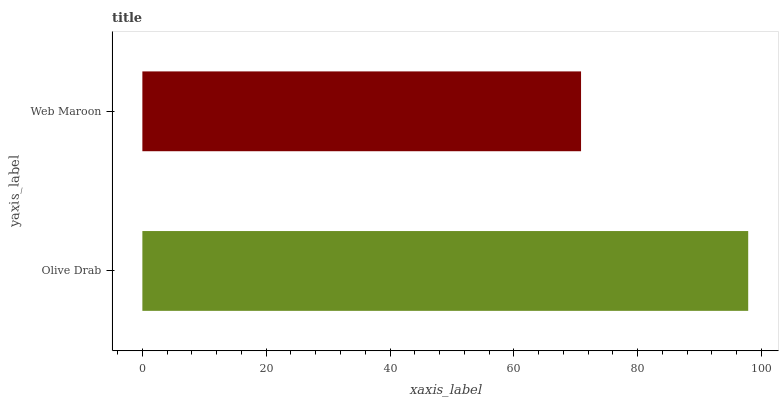Is Web Maroon the minimum?
Answer yes or no. Yes. Is Olive Drab the maximum?
Answer yes or no. Yes. Is Web Maroon the maximum?
Answer yes or no. No. Is Olive Drab greater than Web Maroon?
Answer yes or no. Yes. Is Web Maroon less than Olive Drab?
Answer yes or no. Yes. Is Web Maroon greater than Olive Drab?
Answer yes or no. No. Is Olive Drab less than Web Maroon?
Answer yes or no. No. Is Olive Drab the high median?
Answer yes or no. Yes. Is Web Maroon the low median?
Answer yes or no. Yes. Is Web Maroon the high median?
Answer yes or no. No. Is Olive Drab the low median?
Answer yes or no. No. 